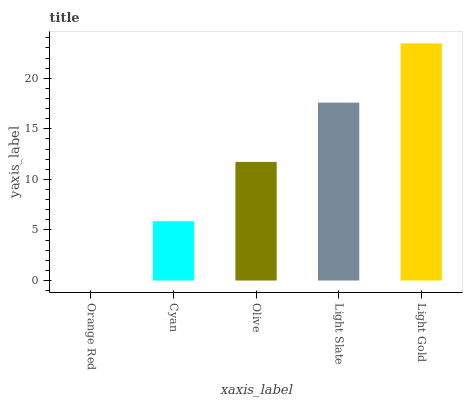Is Orange Red the minimum?
Answer yes or no. Yes. Is Light Gold the maximum?
Answer yes or no. Yes. Is Cyan the minimum?
Answer yes or no. No. Is Cyan the maximum?
Answer yes or no. No. Is Cyan greater than Orange Red?
Answer yes or no. Yes. Is Orange Red less than Cyan?
Answer yes or no. Yes. Is Orange Red greater than Cyan?
Answer yes or no. No. Is Cyan less than Orange Red?
Answer yes or no. No. Is Olive the high median?
Answer yes or no. Yes. Is Olive the low median?
Answer yes or no. Yes. Is Light Slate the high median?
Answer yes or no. No. Is Light Slate the low median?
Answer yes or no. No. 